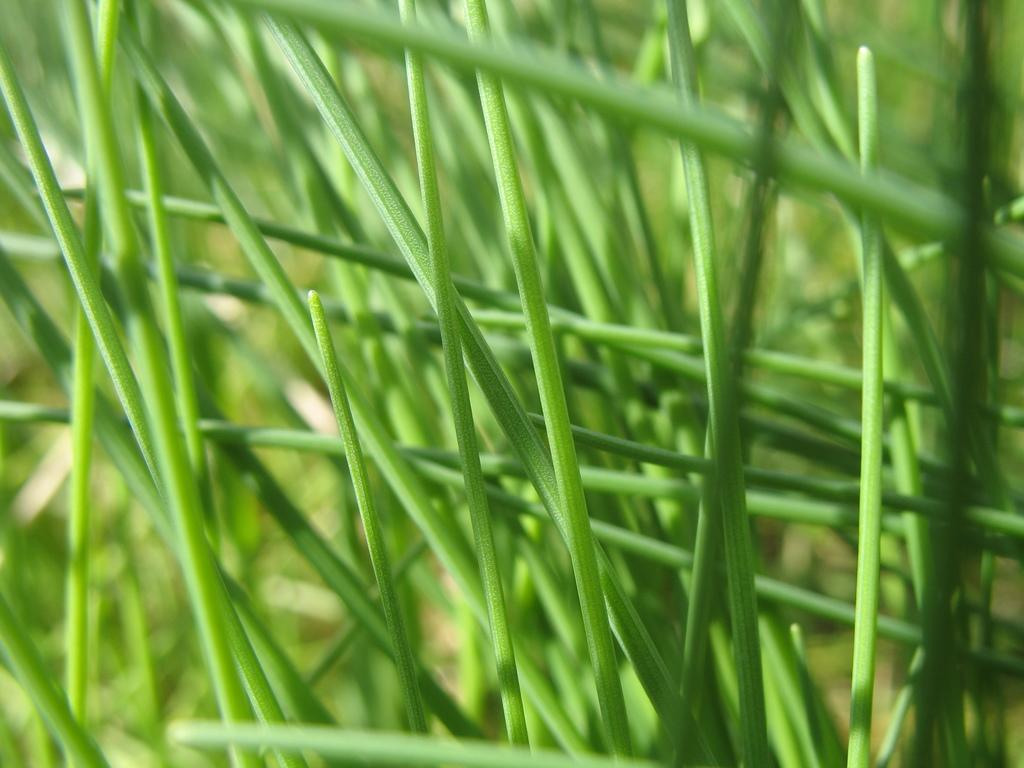What type of plants are visible in the image? There are grass plants in the image. What is the color of the grass plants? The grass plants are green in color. How many cakes are being served in the image? There are no cakes present in the image; it features grass plants. What is the interest rate for the loan in the image? There is no mention of loans or interest rates in the image, as it only features grass plants. 